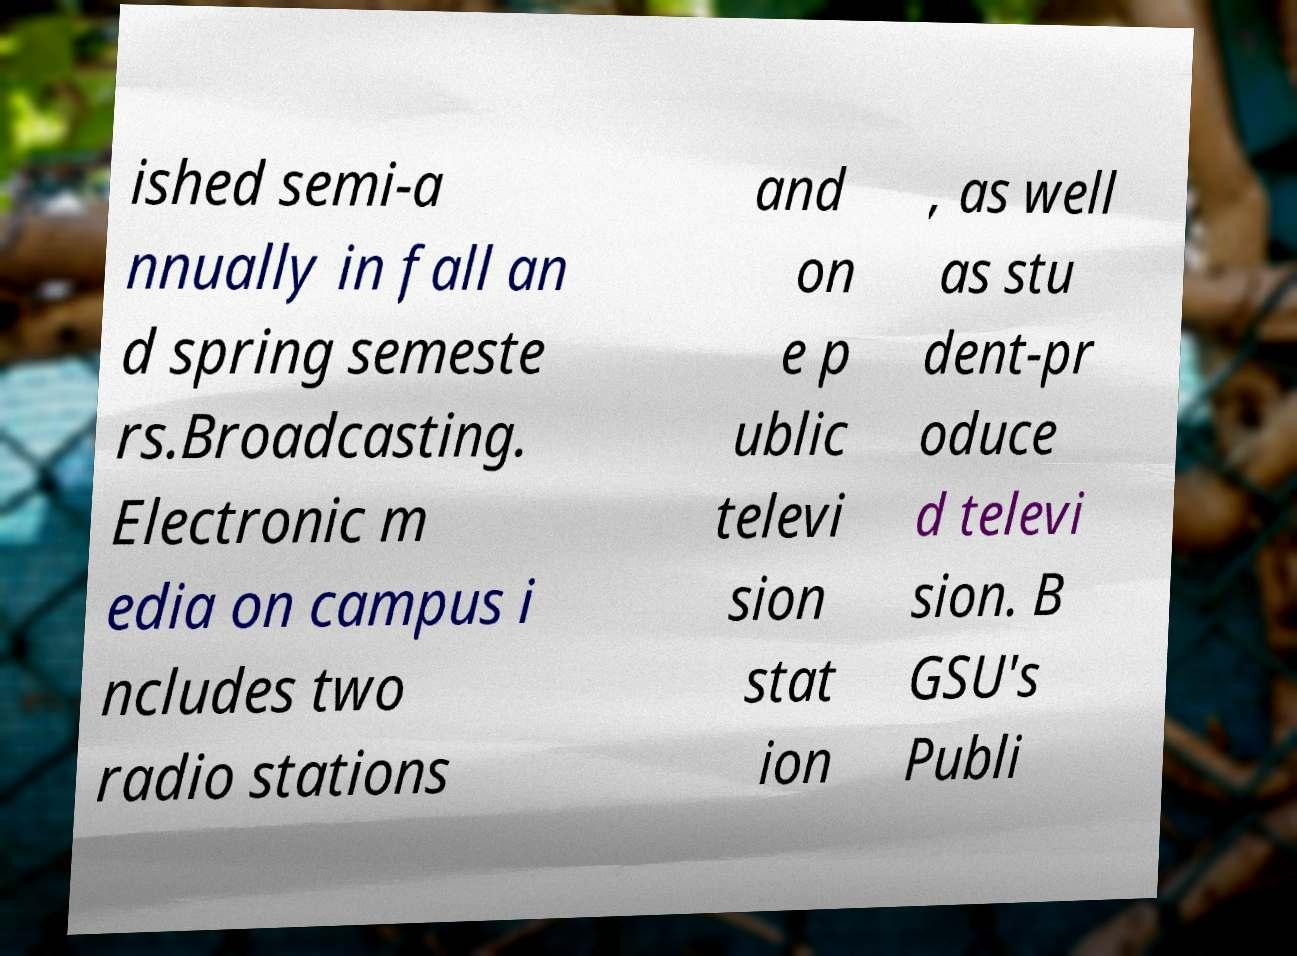Please identify and transcribe the text found in this image. ished semi-a nnually in fall an d spring semeste rs.Broadcasting. Electronic m edia on campus i ncludes two radio stations and on e p ublic televi sion stat ion , as well as stu dent-pr oduce d televi sion. B GSU's Publi 